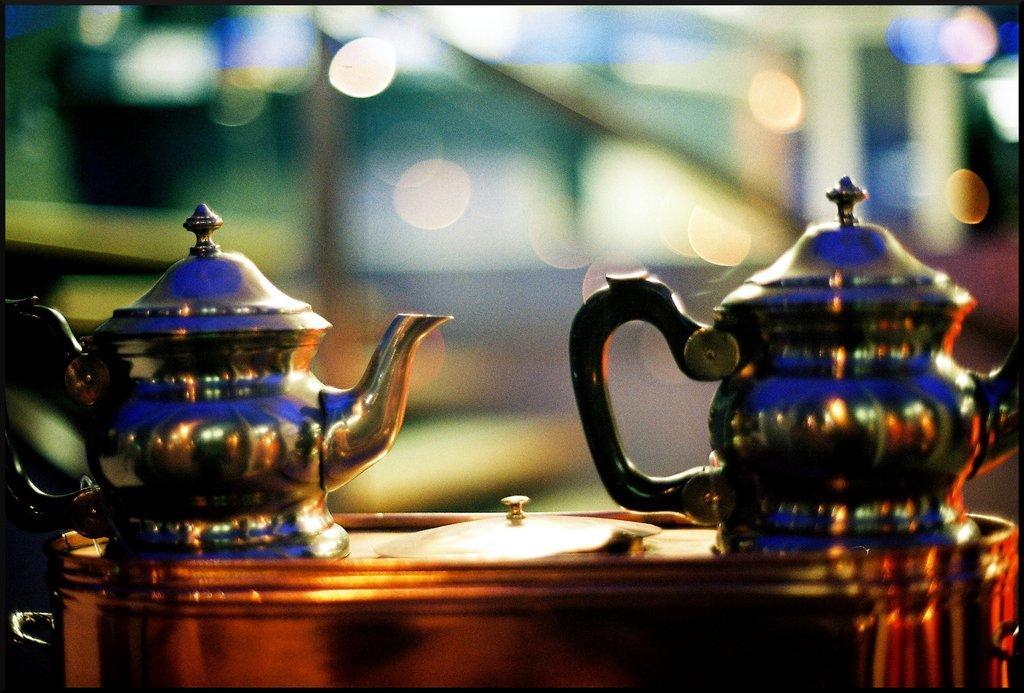Please provide a concise description of this image. In this image we can see some tea jugs on the table and the background is blurred. 